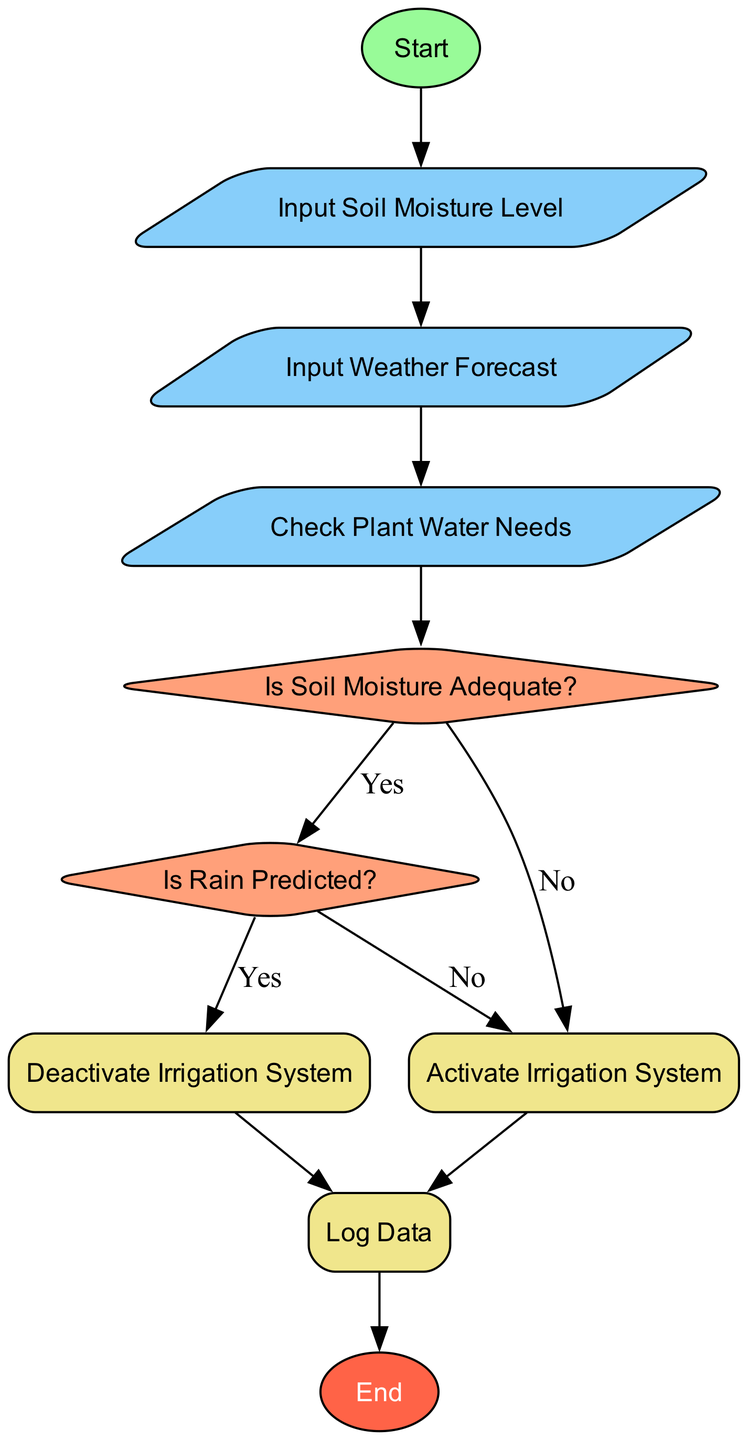What is the first action in the flowchart? The first action in the flowchart is represented by the "Start" node, indicating the beginning of the water management process.
Answer: Start How many decision nodes are present in the diagram? There are two decision nodes in the diagram: "Is Soil Moisture Adequate?" and "Is Rain Predicted?".
Answer: 2 What should be done if the soil moisture level is adequate? If the soil moisture level is adequate, the flowchart indicates to "Deactivate Irrigation System".
Answer: Deactivate Irrigation System What is the next step after checking the plant water needs? The next step after checking the plant water needs is to evaluate whether the soil moisture is adequate or not.
Answer: Is Soil Moisture Adequate? Which node follows after activating the irrigation system? After activating the irrigation system, the next node is "Log Data", where data about moisture levels and irrigation activity is stored.
Answer: Log Data What happens if rain is predicted? If rain is predicted, the flowchart indicates to "Deactivate Irrigation System", as the rainfall will meet the water needs of the plants.
Answer: Deactivate Irrigation System How many processes are in the diagram? The diagram contains three process nodes: "Activate Irrigation System", "Deactivate Irrigation System", and "Log Data".
Answer: 3 What action should be taken if rain is not predicted and soil moisture is inadequate? If rain is not predicted and soil moisture is inadequate, the flowchart instructs to "Activate Irrigation System".
Answer: Activate Irrigation System Which node represents the end of the water management process? The node that represents the end of the water management process is labeled "End".
Answer: End 